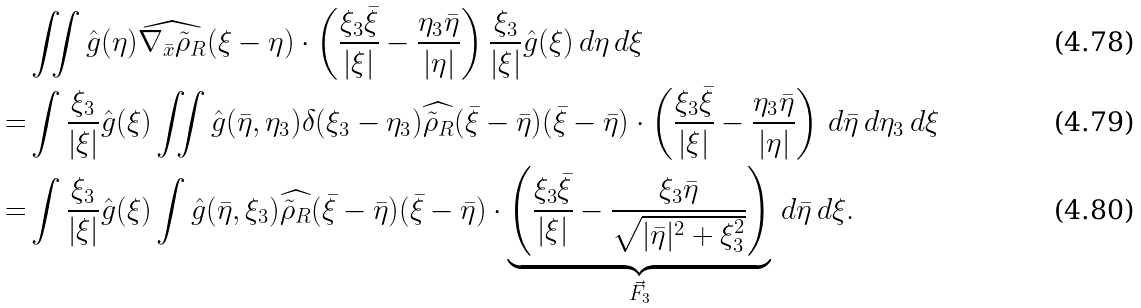<formula> <loc_0><loc_0><loc_500><loc_500>& \iint \hat { g } ( \eta ) \widehat { \nabla _ { \bar { x } } \tilde { \rho } _ { R } } ( \xi - \eta ) \cdot \left ( \frac { \xi _ { 3 } \bar { \xi } } { | \xi | } - \frac { \eta _ { 3 } \bar { \eta } } { | \eta | } \right ) \frac { \xi _ { 3 } } { | \xi | } \hat { g } ( \xi ) \, d \eta \, d \xi \\ = & \int \frac { \xi _ { 3 } } { | \xi | } \hat { g } ( \xi ) \iint \hat { g } ( \bar { \eta } , \eta _ { 3 } ) \delta ( \xi _ { 3 } - \eta _ { 3 } ) \widehat { \tilde { \rho } _ { R } } ( \bar { \xi } - \bar { \eta } ) ( \bar { \xi } - \bar { \eta } ) \cdot \left ( \frac { \xi _ { 3 } \bar { \xi } } { | \xi | } - \frac { \eta _ { 3 } \bar { \eta } } { | \eta | } \right ) \, d \bar { \eta } \, d \eta _ { 3 } \, d \xi \\ = & \int \frac { \xi _ { 3 } } { | \xi | } \hat { g } ( \xi ) \int \hat { g } ( \bar { \eta } , \xi _ { 3 } ) \widehat { \tilde { \rho } _ { R } } ( \bar { \xi } - \bar { \eta } ) ( \bar { \xi } - \bar { \eta } ) \cdot \underbrace { \left ( \frac { \xi _ { 3 } \bar { \xi } } { | \xi | } - \frac { \xi _ { 3 } \bar { \eta } } { \sqrt { | \bar { \eta } | ^ { 2 } + \xi _ { 3 } ^ { 2 } } } \right ) } _ { \vec { F } _ { 3 } } \, d \bar { \eta } \, d \xi .</formula> 